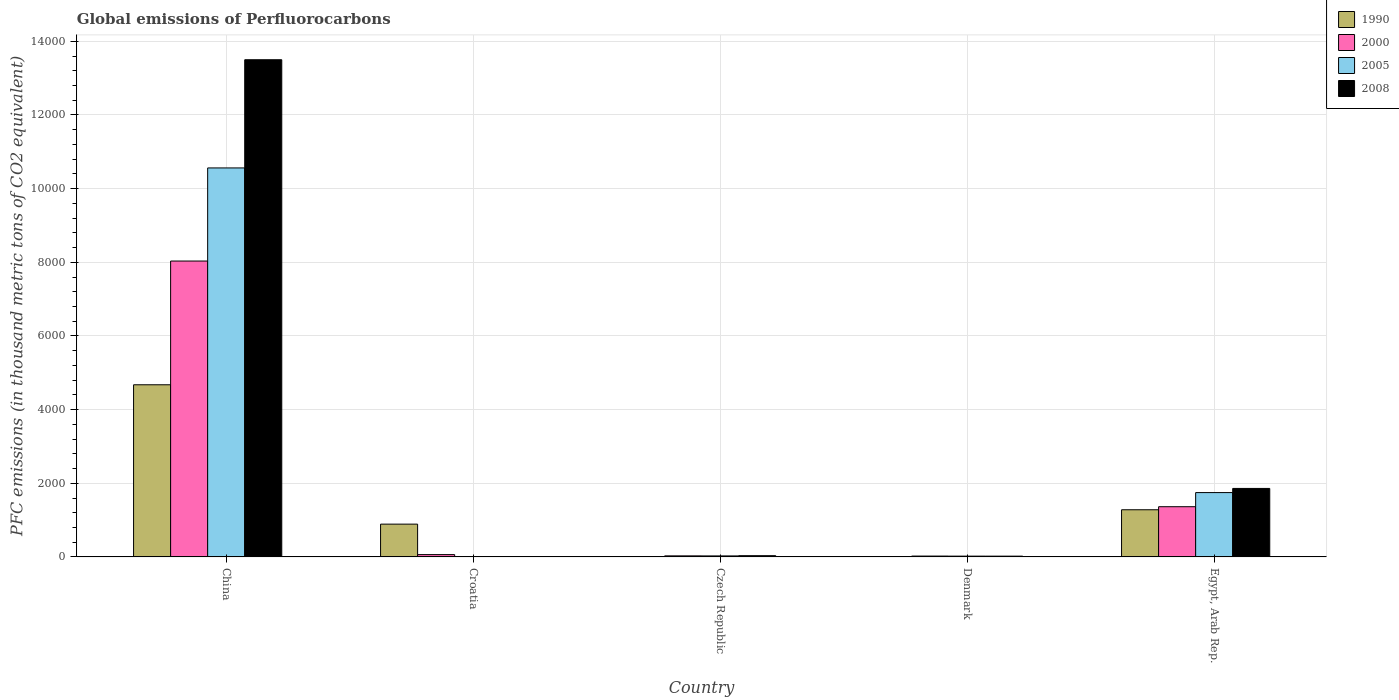Are the number of bars per tick equal to the number of legend labels?
Give a very brief answer. Yes. How many bars are there on the 5th tick from the right?
Your answer should be very brief. 4. Across all countries, what is the maximum global emissions of Perfluorocarbons in 2008?
Your answer should be compact. 1.35e+04. In which country was the global emissions of Perfluorocarbons in 2008 minimum?
Provide a succinct answer. Croatia. What is the total global emissions of Perfluorocarbons in 2008 in the graph?
Keep it short and to the point. 1.54e+04. What is the difference between the global emissions of Perfluorocarbons in 2005 in Croatia and that in Czech Republic?
Your answer should be compact. -16.6. What is the difference between the global emissions of Perfluorocarbons in 1990 in China and the global emissions of Perfluorocarbons in 2000 in Czech Republic?
Provide a succinct answer. 4645.7. What is the average global emissions of Perfluorocarbons in 2000 per country?
Your answer should be compact. 1902.68. What is the difference between the global emissions of Perfluorocarbons of/in 2008 and global emissions of Perfluorocarbons of/in 2005 in China?
Your answer should be very brief. 2937.8. In how many countries, is the global emissions of Perfluorocarbons in 2005 greater than 4800 thousand metric tons?
Offer a terse response. 1. What is the ratio of the global emissions of Perfluorocarbons in 2008 in Croatia to that in Egypt, Arab Rep.?
Your answer should be compact. 0.01. Is the global emissions of Perfluorocarbons in 2005 in Czech Republic less than that in Denmark?
Make the answer very short. No. Is the difference between the global emissions of Perfluorocarbons in 2008 in China and Czech Republic greater than the difference between the global emissions of Perfluorocarbons in 2005 in China and Czech Republic?
Your answer should be very brief. Yes. What is the difference between the highest and the second highest global emissions of Perfluorocarbons in 2008?
Your answer should be very brief. -1826.5. What is the difference between the highest and the lowest global emissions of Perfluorocarbons in 2005?
Your answer should be compact. 1.06e+04. Is it the case that in every country, the sum of the global emissions of Perfluorocarbons in 2008 and global emissions of Perfluorocarbons in 2005 is greater than the sum of global emissions of Perfluorocarbons in 2000 and global emissions of Perfluorocarbons in 1990?
Your answer should be compact. No. What does the 2nd bar from the left in Egypt, Arab Rep. represents?
Provide a short and direct response. 2000. What does the 4th bar from the right in Croatia represents?
Your response must be concise. 1990. How many countries are there in the graph?
Make the answer very short. 5. What is the difference between two consecutive major ticks on the Y-axis?
Give a very brief answer. 2000. Are the values on the major ticks of Y-axis written in scientific E-notation?
Make the answer very short. No. Where does the legend appear in the graph?
Keep it short and to the point. Top right. How many legend labels are there?
Keep it short and to the point. 4. What is the title of the graph?
Ensure brevity in your answer.  Global emissions of Perfluorocarbons. What is the label or title of the Y-axis?
Make the answer very short. PFC emissions (in thousand metric tons of CO2 equivalent). What is the PFC emissions (in thousand metric tons of CO2 equivalent) of 1990 in China?
Make the answer very short. 4674.5. What is the PFC emissions (in thousand metric tons of CO2 equivalent) of 2000 in China?
Your response must be concise. 8034.4. What is the PFC emissions (in thousand metric tons of CO2 equivalent) of 2005 in China?
Make the answer very short. 1.06e+04. What is the PFC emissions (in thousand metric tons of CO2 equivalent) of 2008 in China?
Your answer should be compact. 1.35e+04. What is the PFC emissions (in thousand metric tons of CO2 equivalent) in 1990 in Croatia?
Provide a short and direct response. 890.4. What is the PFC emissions (in thousand metric tons of CO2 equivalent) of 2000 in Croatia?
Offer a terse response. 63. What is the PFC emissions (in thousand metric tons of CO2 equivalent) of 2008 in Croatia?
Ensure brevity in your answer.  11. What is the PFC emissions (in thousand metric tons of CO2 equivalent) of 2000 in Czech Republic?
Make the answer very short. 28.8. What is the PFC emissions (in thousand metric tons of CO2 equivalent) in 2008 in Czech Republic?
Your response must be concise. 33.3. What is the PFC emissions (in thousand metric tons of CO2 equivalent) in 2000 in Denmark?
Offer a terse response. 23.4. What is the PFC emissions (in thousand metric tons of CO2 equivalent) of 2008 in Denmark?
Offer a very short reply. 21.4. What is the PFC emissions (in thousand metric tons of CO2 equivalent) in 1990 in Egypt, Arab Rep.?
Your answer should be very brief. 1280.8. What is the PFC emissions (in thousand metric tons of CO2 equivalent) of 2000 in Egypt, Arab Rep.?
Keep it short and to the point. 1363.8. What is the PFC emissions (in thousand metric tons of CO2 equivalent) of 2005 in Egypt, Arab Rep.?
Make the answer very short. 1747.1. What is the PFC emissions (in thousand metric tons of CO2 equivalent) in 2008 in Egypt, Arab Rep.?
Your answer should be compact. 1859.8. Across all countries, what is the maximum PFC emissions (in thousand metric tons of CO2 equivalent) in 1990?
Provide a short and direct response. 4674.5. Across all countries, what is the maximum PFC emissions (in thousand metric tons of CO2 equivalent) of 2000?
Provide a short and direct response. 8034.4. Across all countries, what is the maximum PFC emissions (in thousand metric tons of CO2 equivalent) in 2005?
Provide a succinct answer. 1.06e+04. Across all countries, what is the maximum PFC emissions (in thousand metric tons of CO2 equivalent) of 2008?
Provide a succinct answer. 1.35e+04. Across all countries, what is the minimum PFC emissions (in thousand metric tons of CO2 equivalent) of 2000?
Give a very brief answer. 23.4. What is the total PFC emissions (in thousand metric tons of CO2 equivalent) in 1990 in the graph?
Your response must be concise. 6849.9. What is the total PFC emissions (in thousand metric tons of CO2 equivalent) in 2000 in the graph?
Offer a terse response. 9513.4. What is the total PFC emissions (in thousand metric tons of CO2 equivalent) in 2005 in the graph?
Offer a very short reply. 1.24e+04. What is the total PFC emissions (in thousand metric tons of CO2 equivalent) of 2008 in the graph?
Offer a terse response. 1.54e+04. What is the difference between the PFC emissions (in thousand metric tons of CO2 equivalent) of 1990 in China and that in Croatia?
Ensure brevity in your answer.  3784.1. What is the difference between the PFC emissions (in thousand metric tons of CO2 equivalent) of 2000 in China and that in Croatia?
Provide a short and direct response. 7971.4. What is the difference between the PFC emissions (in thousand metric tons of CO2 equivalent) in 2005 in China and that in Croatia?
Keep it short and to the point. 1.06e+04. What is the difference between the PFC emissions (in thousand metric tons of CO2 equivalent) in 2008 in China and that in Croatia?
Make the answer very short. 1.35e+04. What is the difference between the PFC emissions (in thousand metric tons of CO2 equivalent) of 1990 in China and that in Czech Republic?
Give a very brief answer. 4671.7. What is the difference between the PFC emissions (in thousand metric tons of CO2 equivalent) in 2000 in China and that in Czech Republic?
Make the answer very short. 8005.6. What is the difference between the PFC emissions (in thousand metric tons of CO2 equivalent) in 2005 in China and that in Czech Republic?
Provide a succinct answer. 1.05e+04. What is the difference between the PFC emissions (in thousand metric tons of CO2 equivalent) of 2008 in China and that in Czech Republic?
Keep it short and to the point. 1.35e+04. What is the difference between the PFC emissions (in thousand metric tons of CO2 equivalent) in 1990 in China and that in Denmark?
Make the answer very short. 4673.1. What is the difference between the PFC emissions (in thousand metric tons of CO2 equivalent) in 2000 in China and that in Denmark?
Provide a short and direct response. 8011. What is the difference between the PFC emissions (in thousand metric tons of CO2 equivalent) of 2005 in China and that in Denmark?
Keep it short and to the point. 1.05e+04. What is the difference between the PFC emissions (in thousand metric tons of CO2 equivalent) of 2008 in China and that in Denmark?
Provide a short and direct response. 1.35e+04. What is the difference between the PFC emissions (in thousand metric tons of CO2 equivalent) in 1990 in China and that in Egypt, Arab Rep.?
Provide a short and direct response. 3393.7. What is the difference between the PFC emissions (in thousand metric tons of CO2 equivalent) in 2000 in China and that in Egypt, Arab Rep.?
Provide a short and direct response. 6670.6. What is the difference between the PFC emissions (in thousand metric tons of CO2 equivalent) of 2005 in China and that in Egypt, Arab Rep.?
Your response must be concise. 8815.7. What is the difference between the PFC emissions (in thousand metric tons of CO2 equivalent) in 2008 in China and that in Egypt, Arab Rep.?
Your answer should be very brief. 1.16e+04. What is the difference between the PFC emissions (in thousand metric tons of CO2 equivalent) of 1990 in Croatia and that in Czech Republic?
Ensure brevity in your answer.  887.6. What is the difference between the PFC emissions (in thousand metric tons of CO2 equivalent) in 2000 in Croatia and that in Czech Republic?
Your answer should be very brief. 34.2. What is the difference between the PFC emissions (in thousand metric tons of CO2 equivalent) of 2005 in Croatia and that in Czech Republic?
Offer a terse response. -16.6. What is the difference between the PFC emissions (in thousand metric tons of CO2 equivalent) of 2008 in Croatia and that in Czech Republic?
Ensure brevity in your answer.  -22.3. What is the difference between the PFC emissions (in thousand metric tons of CO2 equivalent) of 1990 in Croatia and that in Denmark?
Ensure brevity in your answer.  889. What is the difference between the PFC emissions (in thousand metric tons of CO2 equivalent) in 2000 in Croatia and that in Denmark?
Offer a very short reply. 39.6. What is the difference between the PFC emissions (in thousand metric tons of CO2 equivalent) in 2005 in Croatia and that in Denmark?
Ensure brevity in your answer.  -10.6. What is the difference between the PFC emissions (in thousand metric tons of CO2 equivalent) of 2008 in Croatia and that in Denmark?
Provide a short and direct response. -10.4. What is the difference between the PFC emissions (in thousand metric tons of CO2 equivalent) in 1990 in Croatia and that in Egypt, Arab Rep.?
Offer a terse response. -390.4. What is the difference between the PFC emissions (in thousand metric tons of CO2 equivalent) in 2000 in Croatia and that in Egypt, Arab Rep.?
Keep it short and to the point. -1300.8. What is the difference between the PFC emissions (in thousand metric tons of CO2 equivalent) in 2005 in Croatia and that in Egypt, Arab Rep.?
Your answer should be very brief. -1736.2. What is the difference between the PFC emissions (in thousand metric tons of CO2 equivalent) of 2008 in Croatia and that in Egypt, Arab Rep.?
Your answer should be very brief. -1848.8. What is the difference between the PFC emissions (in thousand metric tons of CO2 equivalent) in 1990 in Czech Republic and that in Egypt, Arab Rep.?
Provide a short and direct response. -1278. What is the difference between the PFC emissions (in thousand metric tons of CO2 equivalent) of 2000 in Czech Republic and that in Egypt, Arab Rep.?
Provide a short and direct response. -1335. What is the difference between the PFC emissions (in thousand metric tons of CO2 equivalent) of 2005 in Czech Republic and that in Egypt, Arab Rep.?
Give a very brief answer. -1719.6. What is the difference between the PFC emissions (in thousand metric tons of CO2 equivalent) of 2008 in Czech Republic and that in Egypt, Arab Rep.?
Make the answer very short. -1826.5. What is the difference between the PFC emissions (in thousand metric tons of CO2 equivalent) of 1990 in Denmark and that in Egypt, Arab Rep.?
Make the answer very short. -1279.4. What is the difference between the PFC emissions (in thousand metric tons of CO2 equivalent) in 2000 in Denmark and that in Egypt, Arab Rep.?
Keep it short and to the point. -1340.4. What is the difference between the PFC emissions (in thousand metric tons of CO2 equivalent) in 2005 in Denmark and that in Egypt, Arab Rep.?
Keep it short and to the point. -1725.6. What is the difference between the PFC emissions (in thousand metric tons of CO2 equivalent) of 2008 in Denmark and that in Egypt, Arab Rep.?
Your answer should be compact. -1838.4. What is the difference between the PFC emissions (in thousand metric tons of CO2 equivalent) in 1990 in China and the PFC emissions (in thousand metric tons of CO2 equivalent) in 2000 in Croatia?
Ensure brevity in your answer.  4611.5. What is the difference between the PFC emissions (in thousand metric tons of CO2 equivalent) in 1990 in China and the PFC emissions (in thousand metric tons of CO2 equivalent) in 2005 in Croatia?
Provide a short and direct response. 4663.6. What is the difference between the PFC emissions (in thousand metric tons of CO2 equivalent) of 1990 in China and the PFC emissions (in thousand metric tons of CO2 equivalent) of 2008 in Croatia?
Provide a succinct answer. 4663.5. What is the difference between the PFC emissions (in thousand metric tons of CO2 equivalent) of 2000 in China and the PFC emissions (in thousand metric tons of CO2 equivalent) of 2005 in Croatia?
Give a very brief answer. 8023.5. What is the difference between the PFC emissions (in thousand metric tons of CO2 equivalent) in 2000 in China and the PFC emissions (in thousand metric tons of CO2 equivalent) in 2008 in Croatia?
Provide a succinct answer. 8023.4. What is the difference between the PFC emissions (in thousand metric tons of CO2 equivalent) in 2005 in China and the PFC emissions (in thousand metric tons of CO2 equivalent) in 2008 in Croatia?
Your answer should be compact. 1.06e+04. What is the difference between the PFC emissions (in thousand metric tons of CO2 equivalent) in 1990 in China and the PFC emissions (in thousand metric tons of CO2 equivalent) in 2000 in Czech Republic?
Your answer should be compact. 4645.7. What is the difference between the PFC emissions (in thousand metric tons of CO2 equivalent) of 1990 in China and the PFC emissions (in thousand metric tons of CO2 equivalent) of 2005 in Czech Republic?
Ensure brevity in your answer.  4647. What is the difference between the PFC emissions (in thousand metric tons of CO2 equivalent) of 1990 in China and the PFC emissions (in thousand metric tons of CO2 equivalent) of 2008 in Czech Republic?
Provide a succinct answer. 4641.2. What is the difference between the PFC emissions (in thousand metric tons of CO2 equivalent) in 2000 in China and the PFC emissions (in thousand metric tons of CO2 equivalent) in 2005 in Czech Republic?
Your response must be concise. 8006.9. What is the difference between the PFC emissions (in thousand metric tons of CO2 equivalent) of 2000 in China and the PFC emissions (in thousand metric tons of CO2 equivalent) of 2008 in Czech Republic?
Make the answer very short. 8001.1. What is the difference between the PFC emissions (in thousand metric tons of CO2 equivalent) of 2005 in China and the PFC emissions (in thousand metric tons of CO2 equivalent) of 2008 in Czech Republic?
Give a very brief answer. 1.05e+04. What is the difference between the PFC emissions (in thousand metric tons of CO2 equivalent) in 1990 in China and the PFC emissions (in thousand metric tons of CO2 equivalent) in 2000 in Denmark?
Ensure brevity in your answer.  4651.1. What is the difference between the PFC emissions (in thousand metric tons of CO2 equivalent) of 1990 in China and the PFC emissions (in thousand metric tons of CO2 equivalent) of 2005 in Denmark?
Your answer should be compact. 4653. What is the difference between the PFC emissions (in thousand metric tons of CO2 equivalent) of 1990 in China and the PFC emissions (in thousand metric tons of CO2 equivalent) of 2008 in Denmark?
Your response must be concise. 4653.1. What is the difference between the PFC emissions (in thousand metric tons of CO2 equivalent) of 2000 in China and the PFC emissions (in thousand metric tons of CO2 equivalent) of 2005 in Denmark?
Provide a succinct answer. 8012.9. What is the difference between the PFC emissions (in thousand metric tons of CO2 equivalent) in 2000 in China and the PFC emissions (in thousand metric tons of CO2 equivalent) in 2008 in Denmark?
Provide a succinct answer. 8013. What is the difference between the PFC emissions (in thousand metric tons of CO2 equivalent) in 2005 in China and the PFC emissions (in thousand metric tons of CO2 equivalent) in 2008 in Denmark?
Give a very brief answer. 1.05e+04. What is the difference between the PFC emissions (in thousand metric tons of CO2 equivalent) of 1990 in China and the PFC emissions (in thousand metric tons of CO2 equivalent) of 2000 in Egypt, Arab Rep.?
Make the answer very short. 3310.7. What is the difference between the PFC emissions (in thousand metric tons of CO2 equivalent) of 1990 in China and the PFC emissions (in thousand metric tons of CO2 equivalent) of 2005 in Egypt, Arab Rep.?
Offer a very short reply. 2927.4. What is the difference between the PFC emissions (in thousand metric tons of CO2 equivalent) in 1990 in China and the PFC emissions (in thousand metric tons of CO2 equivalent) in 2008 in Egypt, Arab Rep.?
Provide a short and direct response. 2814.7. What is the difference between the PFC emissions (in thousand metric tons of CO2 equivalent) of 2000 in China and the PFC emissions (in thousand metric tons of CO2 equivalent) of 2005 in Egypt, Arab Rep.?
Offer a terse response. 6287.3. What is the difference between the PFC emissions (in thousand metric tons of CO2 equivalent) of 2000 in China and the PFC emissions (in thousand metric tons of CO2 equivalent) of 2008 in Egypt, Arab Rep.?
Keep it short and to the point. 6174.6. What is the difference between the PFC emissions (in thousand metric tons of CO2 equivalent) of 2005 in China and the PFC emissions (in thousand metric tons of CO2 equivalent) of 2008 in Egypt, Arab Rep.?
Your response must be concise. 8703. What is the difference between the PFC emissions (in thousand metric tons of CO2 equivalent) of 1990 in Croatia and the PFC emissions (in thousand metric tons of CO2 equivalent) of 2000 in Czech Republic?
Your answer should be very brief. 861.6. What is the difference between the PFC emissions (in thousand metric tons of CO2 equivalent) of 1990 in Croatia and the PFC emissions (in thousand metric tons of CO2 equivalent) of 2005 in Czech Republic?
Keep it short and to the point. 862.9. What is the difference between the PFC emissions (in thousand metric tons of CO2 equivalent) in 1990 in Croatia and the PFC emissions (in thousand metric tons of CO2 equivalent) in 2008 in Czech Republic?
Keep it short and to the point. 857.1. What is the difference between the PFC emissions (in thousand metric tons of CO2 equivalent) in 2000 in Croatia and the PFC emissions (in thousand metric tons of CO2 equivalent) in 2005 in Czech Republic?
Make the answer very short. 35.5. What is the difference between the PFC emissions (in thousand metric tons of CO2 equivalent) of 2000 in Croatia and the PFC emissions (in thousand metric tons of CO2 equivalent) of 2008 in Czech Republic?
Give a very brief answer. 29.7. What is the difference between the PFC emissions (in thousand metric tons of CO2 equivalent) in 2005 in Croatia and the PFC emissions (in thousand metric tons of CO2 equivalent) in 2008 in Czech Republic?
Keep it short and to the point. -22.4. What is the difference between the PFC emissions (in thousand metric tons of CO2 equivalent) in 1990 in Croatia and the PFC emissions (in thousand metric tons of CO2 equivalent) in 2000 in Denmark?
Your answer should be compact. 867. What is the difference between the PFC emissions (in thousand metric tons of CO2 equivalent) of 1990 in Croatia and the PFC emissions (in thousand metric tons of CO2 equivalent) of 2005 in Denmark?
Provide a short and direct response. 868.9. What is the difference between the PFC emissions (in thousand metric tons of CO2 equivalent) in 1990 in Croatia and the PFC emissions (in thousand metric tons of CO2 equivalent) in 2008 in Denmark?
Give a very brief answer. 869. What is the difference between the PFC emissions (in thousand metric tons of CO2 equivalent) in 2000 in Croatia and the PFC emissions (in thousand metric tons of CO2 equivalent) in 2005 in Denmark?
Make the answer very short. 41.5. What is the difference between the PFC emissions (in thousand metric tons of CO2 equivalent) of 2000 in Croatia and the PFC emissions (in thousand metric tons of CO2 equivalent) of 2008 in Denmark?
Provide a short and direct response. 41.6. What is the difference between the PFC emissions (in thousand metric tons of CO2 equivalent) of 1990 in Croatia and the PFC emissions (in thousand metric tons of CO2 equivalent) of 2000 in Egypt, Arab Rep.?
Your response must be concise. -473.4. What is the difference between the PFC emissions (in thousand metric tons of CO2 equivalent) in 1990 in Croatia and the PFC emissions (in thousand metric tons of CO2 equivalent) in 2005 in Egypt, Arab Rep.?
Offer a terse response. -856.7. What is the difference between the PFC emissions (in thousand metric tons of CO2 equivalent) of 1990 in Croatia and the PFC emissions (in thousand metric tons of CO2 equivalent) of 2008 in Egypt, Arab Rep.?
Give a very brief answer. -969.4. What is the difference between the PFC emissions (in thousand metric tons of CO2 equivalent) in 2000 in Croatia and the PFC emissions (in thousand metric tons of CO2 equivalent) in 2005 in Egypt, Arab Rep.?
Your answer should be very brief. -1684.1. What is the difference between the PFC emissions (in thousand metric tons of CO2 equivalent) of 2000 in Croatia and the PFC emissions (in thousand metric tons of CO2 equivalent) of 2008 in Egypt, Arab Rep.?
Offer a very short reply. -1796.8. What is the difference between the PFC emissions (in thousand metric tons of CO2 equivalent) in 2005 in Croatia and the PFC emissions (in thousand metric tons of CO2 equivalent) in 2008 in Egypt, Arab Rep.?
Ensure brevity in your answer.  -1848.9. What is the difference between the PFC emissions (in thousand metric tons of CO2 equivalent) of 1990 in Czech Republic and the PFC emissions (in thousand metric tons of CO2 equivalent) of 2000 in Denmark?
Your answer should be compact. -20.6. What is the difference between the PFC emissions (in thousand metric tons of CO2 equivalent) in 1990 in Czech Republic and the PFC emissions (in thousand metric tons of CO2 equivalent) in 2005 in Denmark?
Make the answer very short. -18.7. What is the difference between the PFC emissions (in thousand metric tons of CO2 equivalent) of 1990 in Czech Republic and the PFC emissions (in thousand metric tons of CO2 equivalent) of 2008 in Denmark?
Your response must be concise. -18.6. What is the difference between the PFC emissions (in thousand metric tons of CO2 equivalent) in 2000 in Czech Republic and the PFC emissions (in thousand metric tons of CO2 equivalent) in 2005 in Denmark?
Provide a succinct answer. 7.3. What is the difference between the PFC emissions (in thousand metric tons of CO2 equivalent) in 2000 in Czech Republic and the PFC emissions (in thousand metric tons of CO2 equivalent) in 2008 in Denmark?
Give a very brief answer. 7.4. What is the difference between the PFC emissions (in thousand metric tons of CO2 equivalent) in 1990 in Czech Republic and the PFC emissions (in thousand metric tons of CO2 equivalent) in 2000 in Egypt, Arab Rep.?
Your answer should be compact. -1361. What is the difference between the PFC emissions (in thousand metric tons of CO2 equivalent) in 1990 in Czech Republic and the PFC emissions (in thousand metric tons of CO2 equivalent) in 2005 in Egypt, Arab Rep.?
Provide a short and direct response. -1744.3. What is the difference between the PFC emissions (in thousand metric tons of CO2 equivalent) of 1990 in Czech Republic and the PFC emissions (in thousand metric tons of CO2 equivalent) of 2008 in Egypt, Arab Rep.?
Offer a terse response. -1857. What is the difference between the PFC emissions (in thousand metric tons of CO2 equivalent) of 2000 in Czech Republic and the PFC emissions (in thousand metric tons of CO2 equivalent) of 2005 in Egypt, Arab Rep.?
Provide a short and direct response. -1718.3. What is the difference between the PFC emissions (in thousand metric tons of CO2 equivalent) of 2000 in Czech Republic and the PFC emissions (in thousand metric tons of CO2 equivalent) of 2008 in Egypt, Arab Rep.?
Keep it short and to the point. -1831. What is the difference between the PFC emissions (in thousand metric tons of CO2 equivalent) of 2005 in Czech Republic and the PFC emissions (in thousand metric tons of CO2 equivalent) of 2008 in Egypt, Arab Rep.?
Your answer should be very brief. -1832.3. What is the difference between the PFC emissions (in thousand metric tons of CO2 equivalent) of 1990 in Denmark and the PFC emissions (in thousand metric tons of CO2 equivalent) of 2000 in Egypt, Arab Rep.?
Provide a succinct answer. -1362.4. What is the difference between the PFC emissions (in thousand metric tons of CO2 equivalent) in 1990 in Denmark and the PFC emissions (in thousand metric tons of CO2 equivalent) in 2005 in Egypt, Arab Rep.?
Provide a short and direct response. -1745.7. What is the difference between the PFC emissions (in thousand metric tons of CO2 equivalent) of 1990 in Denmark and the PFC emissions (in thousand metric tons of CO2 equivalent) of 2008 in Egypt, Arab Rep.?
Offer a very short reply. -1858.4. What is the difference between the PFC emissions (in thousand metric tons of CO2 equivalent) of 2000 in Denmark and the PFC emissions (in thousand metric tons of CO2 equivalent) of 2005 in Egypt, Arab Rep.?
Ensure brevity in your answer.  -1723.7. What is the difference between the PFC emissions (in thousand metric tons of CO2 equivalent) in 2000 in Denmark and the PFC emissions (in thousand metric tons of CO2 equivalent) in 2008 in Egypt, Arab Rep.?
Your answer should be very brief. -1836.4. What is the difference between the PFC emissions (in thousand metric tons of CO2 equivalent) of 2005 in Denmark and the PFC emissions (in thousand metric tons of CO2 equivalent) of 2008 in Egypt, Arab Rep.?
Keep it short and to the point. -1838.3. What is the average PFC emissions (in thousand metric tons of CO2 equivalent) of 1990 per country?
Your answer should be very brief. 1369.98. What is the average PFC emissions (in thousand metric tons of CO2 equivalent) of 2000 per country?
Ensure brevity in your answer.  1902.68. What is the average PFC emissions (in thousand metric tons of CO2 equivalent) of 2005 per country?
Provide a succinct answer. 2473.96. What is the average PFC emissions (in thousand metric tons of CO2 equivalent) of 2008 per country?
Your response must be concise. 3085.22. What is the difference between the PFC emissions (in thousand metric tons of CO2 equivalent) of 1990 and PFC emissions (in thousand metric tons of CO2 equivalent) of 2000 in China?
Provide a short and direct response. -3359.9. What is the difference between the PFC emissions (in thousand metric tons of CO2 equivalent) of 1990 and PFC emissions (in thousand metric tons of CO2 equivalent) of 2005 in China?
Offer a very short reply. -5888.3. What is the difference between the PFC emissions (in thousand metric tons of CO2 equivalent) in 1990 and PFC emissions (in thousand metric tons of CO2 equivalent) in 2008 in China?
Make the answer very short. -8826.1. What is the difference between the PFC emissions (in thousand metric tons of CO2 equivalent) in 2000 and PFC emissions (in thousand metric tons of CO2 equivalent) in 2005 in China?
Your answer should be very brief. -2528.4. What is the difference between the PFC emissions (in thousand metric tons of CO2 equivalent) of 2000 and PFC emissions (in thousand metric tons of CO2 equivalent) of 2008 in China?
Your answer should be compact. -5466.2. What is the difference between the PFC emissions (in thousand metric tons of CO2 equivalent) in 2005 and PFC emissions (in thousand metric tons of CO2 equivalent) in 2008 in China?
Provide a short and direct response. -2937.8. What is the difference between the PFC emissions (in thousand metric tons of CO2 equivalent) in 1990 and PFC emissions (in thousand metric tons of CO2 equivalent) in 2000 in Croatia?
Provide a succinct answer. 827.4. What is the difference between the PFC emissions (in thousand metric tons of CO2 equivalent) in 1990 and PFC emissions (in thousand metric tons of CO2 equivalent) in 2005 in Croatia?
Offer a very short reply. 879.5. What is the difference between the PFC emissions (in thousand metric tons of CO2 equivalent) of 1990 and PFC emissions (in thousand metric tons of CO2 equivalent) of 2008 in Croatia?
Your answer should be compact. 879.4. What is the difference between the PFC emissions (in thousand metric tons of CO2 equivalent) of 2000 and PFC emissions (in thousand metric tons of CO2 equivalent) of 2005 in Croatia?
Make the answer very short. 52.1. What is the difference between the PFC emissions (in thousand metric tons of CO2 equivalent) in 1990 and PFC emissions (in thousand metric tons of CO2 equivalent) in 2005 in Czech Republic?
Make the answer very short. -24.7. What is the difference between the PFC emissions (in thousand metric tons of CO2 equivalent) of 1990 and PFC emissions (in thousand metric tons of CO2 equivalent) of 2008 in Czech Republic?
Offer a terse response. -30.5. What is the difference between the PFC emissions (in thousand metric tons of CO2 equivalent) in 2000 and PFC emissions (in thousand metric tons of CO2 equivalent) in 2005 in Czech Republic?
Offer a very short reply. 1.3. What is the difference between the PFC emissions (in thousand metric tons of CO2 equivalent) in 1990 and PFC emissions (in thousand metric tons of CO2 equivalent) in 2005 in Denmark?
Your answer should be compact. -20.1. What is the difference between the PFC emissions (in thousand metric tons of CO2 equivalent) in 2000 and PFC emissions (in thousand metric tons of CO2 equivalent) in 2005 in Denmark?
Your response must be concise. 1.9. What is the difference between the PFC emissions (in thousand metric tons of CO2 equivalent) of 2000 and PFC emissions (in thousand metric tons of CO2 equivalent) of 2008 in Denmark?
Ensure brevity in your answer.  2. What is the difference between the PFC emissions (in thousand metric tons of CO2 equivalent) of 1990 and PFC emissions (in thousand metric tons of CO2 equivalent) of 2000 in Egypt, Arab Rep.?
Provide a succinct answer. -83. What is the difference between the PFC emissions (in thousand metric tons of CO2 equivalent) of 1990 and PFC emissions (in thousand metric tons of CO2 equivalent) of 2005 in Egypt, Arab Rep.?
Your answer should be very brief. -466.3. What is the difference between the PFC emissions (in thousand metric tons of CO2 equivalent) of 1990 and PFC emissions (in thousand metric tons of CO2 equivalent) of 2008 in Egypt, Arab Rep.?
Provide a short and direct response. -579. What is the difference between the PFC emissions (in thousand metric tons of CO2 equivalent) in 2000 and PFC emissions (in thousand metric tons of CO2 equivalent) in 2005 in Egypt, Arab Rep.?
Your answer should be very brief. -383.3. What is the difference between the PFC emissions (in thousand metric tons of CO2 equivalent) of 2000 and PFC emissions (in thousand metric tons of CO2 equivalent) of 2008 in Egypt, Arab Rep.?
Keep it short and to the point. -496. What is the difference between the PFC emissions (in thousand metric tons of CO2 equivalent) in 2005 and PFC emissions (in thousand metric tons of CO2 equivalent) in 2008 in Egypt, Arab Rep.?
Give a very brief answer. -112.7. What is the ratio of the PFC emissions (in thousand metric tons of CO2 equivalent) of 1990 in China to that in Croatia?
Provide a succinct answer. 5.25. What is the ratio of the PFC emissions (in thousand metric tons of CO2 equivalent) in 2000 in China to that in Croatia?
Provide a short and direct response. 127.53. What is the ratio of the PFC emissions (in thousand metric tons of CO2 equivalent) of 2005 in China to that in Croatia?
Provide a succinct answer. 969.06. What is the ratio of the PFC emissions (in thousand metric tons of CO2 equivalent) of 2008 in China to that in Croatia?
Offer a terse response. 1227.33. What is the ratio of the PFC emissions (in thousand metric tons of CO2 equivalent) of 1990 in China to that in Czech Republic?
Make the answer very short. 1669.46. What is the ratio of the PFC emissions (in thousand metric tons of CO2 equivalent) of 2000 in China to that in Czech Republic?
Give a very brief answer. 278.97. What is the ratio of the PFC emissions (in thousand metric tons of CO2 equivalent) of 2005 in China to that in Czech Republic?
Offer a terse response. 384.1. What is the ratio of the PFC emissions (in thousand metric tons of CO2 equivalent) in 2008 in China to that in Czech Republic?
Your answer should be very brief. 405.42. What is the ratio of the PFC emissions (in thousand metric tons of CO2 equivalent) of 1990 in China to that in Denmark?
Offer a terse response. 3338.93. What is the ratio of the PFC emissions (in thousand metric tons of CO2 equivalent) in 2000 in China to that in Denmark?
Keep it short and to the point. 343.35. What is the ratio of the PFC emissions (in thousand metric tons of CO2 equivalent) of 2005 in China to that in Denmark?
Provide a short and direct response. 491.29. What is the ratio of the PFC emissions (in thousand metric tons of CO2 equivalent) of 2008 in China to that in Denmark?
Give a very brief answer. 630.87. What is the ratio of the PFC emissions (in thousand metric tons of CO2 equivalent) in 1990 in China to that in Egypt, Arab Rep.?
Ensure brevity in your answer.  3.65. What is the ratio of the PFC emissions (in thousand metric tons of CO2 equivalent) in 2000 in China to that in Egypt, Arab Rep.?
Your answer should be compact. 5.89. What is the ratio of the PFC emissions (in thousand metric tons of CO2 equivalent) in 2005 in China to that in Egypt, Arab Rep.?
Make the answer very short. 6.05. What is the ratio of the PFC emissions (in thousand metric tons of CO2 equivalent) in 2008 in China to that in Egypt, Arab Rep.?
Your answer should be very brief. 7.26. What is the ratio of the PFC emissions (in thousand metric tons of CO2 equivalent) in 1990 in Croatia to that in Czech Republic?
Your response must be concise. 318. What is the ratio of the PFC emissions (in thousand metric tons of CO2 equivalent) of 2000 in Croatia to that in Czech Republic?
Ensure brevity in your answer.  2.19. What is the ratio of the PFC emissions (in thousand metric tons of CO2 equivalent) of 2005 in Croatia to that in Czech Republic?
Your answer should be compact. 0.4. What is the ratio of the PFC emissions (in thousand metric tons of CO2 equivalent) in 2008 in Croatia to that in Czech Republic?
Your answer should be compact. 0.33. What is the ratio of the PFC emissions (in thousand metric tons of CO2 equivalent) in 1990 in Croatia to that in Denmark?
Offer a terse response. 636. What is the ratio of the PFC emissions (in thousand metric tons of CO2 equivalent) of 2000 in Croatia to that in Denmark?
Offer a very short reply. 2.69. What is the ratio of the PFC emissions (in thousand metric tons of CO2 equivalent) of 2005 in Croatia to that in Denmark?
Your answer should be compact. 0.51. What is the ratio of the PFC emissions (in thousand metric tons of CO2 equivalent) in 2008 in Croatia to that in Denmark?
Your answer should be very brief. 0.51. What is the ratio of the PFC emissions (in thousand metric tons of CO2 equivalent) in 1990 in Croatia to that in Egypt, Arab Rep.?
Offer a very short reply. 0.7. What is the ratio of the PFC emissions (in thousand metric tons of CO2 equivalent) of 2000 in Croatia to that in Egypt, Arab Rep.?
Your answer should be very brief. 0.05. What is the ratio of the PFC emissions (in thousand metric tons of CO2 equivalent) of 2005 in Croatia to that in Egypt, Arab Rep.?
Offer a terse response. 0.01. What is the ratio of the PFC emissions (in thousand metric tons of CO2 equivalent) in 2008 in Croatia to that in Egypt, Arab Rep.?
Make the answer very short. 0.01. What is the ratio of the PFC emissions (in thousand metric tons of CO2 equivalent) in 2000 in Czech Republic to that in Denmark?
Provide a short and direct response. 1.23. What is the ratio of the PFC emissions (in thousand metric tons of CO2 equivalent) in 2005 in Czech Republic to that in Denmark?
Give a very brief answer. 1.28. What is the ratio of the PFC emissions (in thousand metric tons of CO2 equivalent) in 2008 in Czech Republic to that in Denmark?
Offer a terse response. 1.56. What is the ratio of the PFC emissions (in thousand metric tons of CO2 equivalent) in 1990 in Czech Republic to that in Egypt, Arab Rep.?
Give a very brief answer. 0. What is the ratio of the PFC emissions (in thousand metric tons of CO2 equivalent) of 2000 in Czech Republic to that in Egypt, Arab Rep.?
Provide a succinct answer. 0.02. What is the ratio of the PFC emissions (in thousand metric tons of CO2 equivalent) in 2005 in Czech Republic to that in Egypt, Arab Rep.?
Provide a short and direct response. 0.02. What is the ratio of the PFC emissions (in thousand metric tons of CO2 equivalent) in 2008 in Czech Republic to that in Egypt, Arab Rep.?
Give a very brief answer. 0.02. What is the ratio of the PFC emissions (in thousand metric tons of CO2 equivalent) of 1990 in Denmark to that in Egypt, Arab Rep.?
Make the answer very short. 0. What is the ratio of the PFC emissions (in thousand metric tons of CO2 equivalent) in 2000 in Denmark to that in Egypt, Arab Rep.?
Provide a succinct answer. 0.02. What is the ratio of the PFC emissions (in thousand metric tons of CO2 equivalent) in 2005 in Denmark to that in Egypt, Arab Rep.?
Give a very brief answer. 0.01. What is the ratio of the PFC emissions (in thousand metric tons of CO2 equivalent) of 2008 in Denmark to that in Egypt, Arab Rep.?
Offer a terse response. 0.01. What is the difference between the highest and the second highest PFC emissions (in thousand metric tons of CO2 equivalent) of 1990?
Provide a short and direct response. 3393.7. What is the difference between the highest and the second highest PFC emissions (in thousand metric tons of CO2 equivalent) of 2000?
Ensure brevity in your answer.  6670.6. What is the difference between the highest and the second highest PFC emissions (in thousand metric tons of CO2 equivalent) of 2005?
Ensure brevity in your answer.  8815.7. What is the difference between the highest and the second highest PFC emissions (in thousand metric tons of CO2 equivalent) in 2008?
Keep it short and to the point. 1.16e+04. What is the difference between the highest and the lowest PFC emissions (in thousand metric tons of CO2 equivalent) of 1990?
Provide a succinct answer. 4673.1. What is the difference between the highest and the lowest PFC emissions (in thousand metric tons of CO2 equivalent) of 2000?
Offer a very short reply. 8011. What is the difference between the highest and the lowest PFC emissions (in thousand metric tons of CO2 equivalent) of 2005?
Provide a short and direct response. 1.06e+04. What is the difference between the highest and the lowest PFC emissions (in thousand metric tons of CO2 equivalent) in 2008?
Provide a succinct answer. 1.35e+04. 